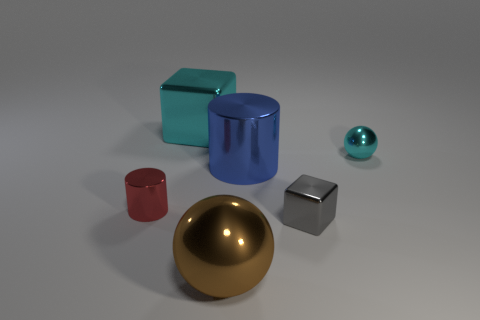Is the color of the big cube the same as the tiny sphere?
Your answer should be compact. Yes. Are there any brown objects of the same size as the cyan block?
Offer a very short reply. Yes. What number of small cyan metal spheres are there?
Provide a short and direct response. 1. What number of large objects are either blue objects or spheres?
Provide a succinct answer. 2. The metal cylinder in front of the large shiny thing that is to the right of the shiny ball that is to the left of the small cyan shiny sphere is what color?
Your response must be concise. Red. How many other things are the same color as the large cube?
Your answer should be very brief. 1. How many rubber things are either large green things or large brown things?
Your answer should be compact. 0. Does the thing behind the tiny cyan thing have the same color as the shiny object in front of the tiny gray metallic block?
Give a very brief answer. No. Is there any other thing that has the same material as the brown sphere?
Provide a succinct answer. Yes. There is a cyan object that is the same shape as the big brown object; what is its size?
Keep it short and to the point. Small. 